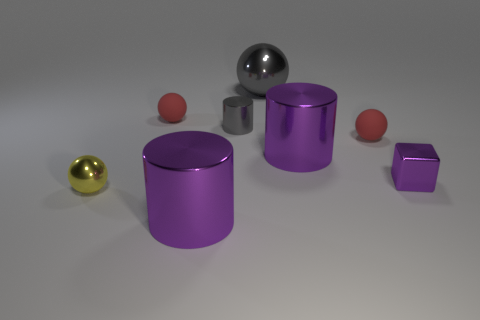How many objects are there in total, and can you describe their shapes? There are a total of six objects in the image. There are two spheres, one large and one small, both with smooth, rounded surfaces. Additionally, there are two cylinders with flat circular tops and bottoms, and smooth curved sides. Lastly, there are two cubes, one larger and one smaller, each with six equal square faces and sharp edges. 